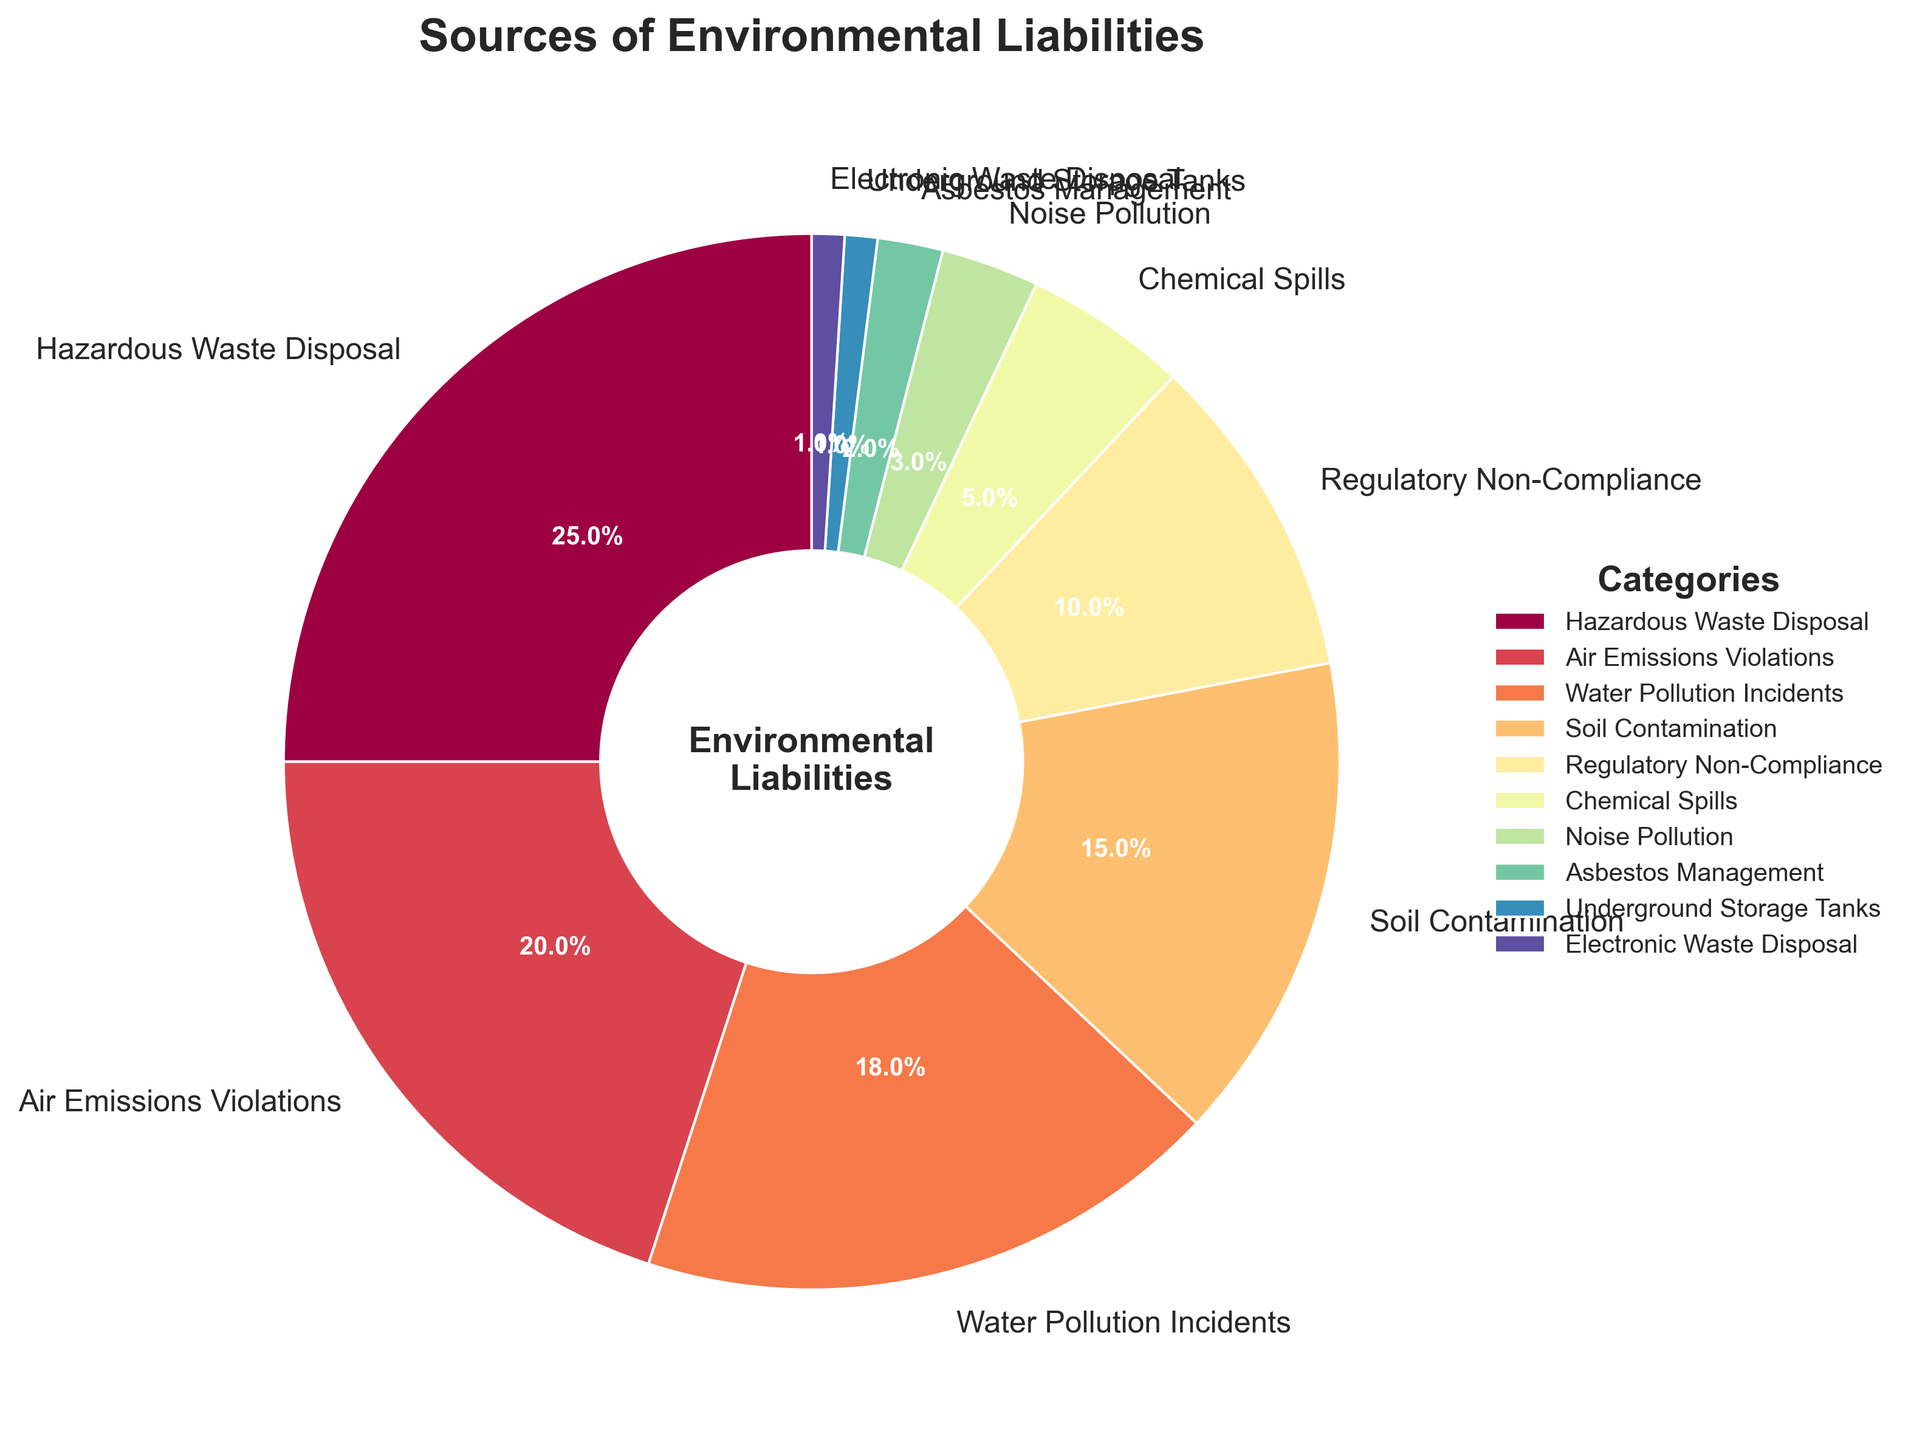What percentage of environmental liabilities is attributed to Hazardous Waste Disposal? Hazardous Waste Disposal is clearly labeled on the pie chart segment, showing a percentage of 25%.
Answer: 25% What is the combined percentage of Air Emissions Violations and Water Pollution Incidents? Add the percentages of Air Emissions Violations (20%) and Water Pollution Incidents (18%), which are next to each other on the pie chart. The combination is 20% + 18% = 38%.
Answer: 38% Which category has the smallest contribution to environmental liabilities? By examining the proportion sizes on the pie chart, Electronic Waste Disposal and Underground Storage Tanks both share the smallest slice, each labeled as 1%.
Answer: Electronic Waste Disposal, Underground Storage Tanks Is the percentage for Soil Contamination larger or smaller than for Regulatory Non-Compliance? Comparing the labeled percentages for the segments, Soil Contamination is marked as 15% while Regulatory Non-Compliance is marked as 10%, thus Soil Contamination is larger.
Answer: Larger How many categories have a percentage below 5%? Identify and count all segments with labels showing percentages below 5%: Chemical Spills (5%), Noise Pollution (3%), Asbestos Management (2%), Underground Storage Tanks (1%), Electronic Waste Disposal (1%). There are 5 such categories.
Answer: 5 What's the difference in percentage between the largest and smallest liability sources? Identify the largest segment, Hazardous Waste Disposal (25%), and the smallest segments, such as Electronic Waste Disposal and Underground Storage Tanks (both 1%). Compute the difference: 25% - 1% = 24%.
Answer: 24% Are the combined percentages of Noise Pollution and Asbestos Management equal to or greater than the percentage of Chemical Spills? Add the percentages of Noise Pollution (3%) and Asbestos Management (2%), which sum to 3% + 2% = 5%, then compare to Chemical Spills (5%). They are equal.
Answer: Equal to Which category related to waste is the largest contributor to environmental liabilities? From the sections related to waste (Hazardous Waste Disposal, Chemical Spills, Electronic Waste Disposal), Hazardous Waste Disposal has the highest percentage of 25%.
Answer: Hazardous Waste Disposal What is the combined contribution of all categories that individually contribute less than 10% to the total environmental liabilities? Sum the percentages of categories each below 10%: Chemical Spills (5%) + Noise Pollution (3%) + Asbestos Management (2%) + Underground Storage Tanks (1%) + Electronic Waste Disposal (1%). Total is 5% + 3% + 2% + 1% + 1% = 12%.
Answer: 12% Does Air Emissions Violations contribute more or less than twice the percentage of Noise Pollution? Air Emissions Violations is 20%, and Noise Pollution is 3%. Twice Noise Pollution is 2 * 3% = 6%. Since 20% > 6%, Air Emissions Violations contribute more than twice.
Answer: More 